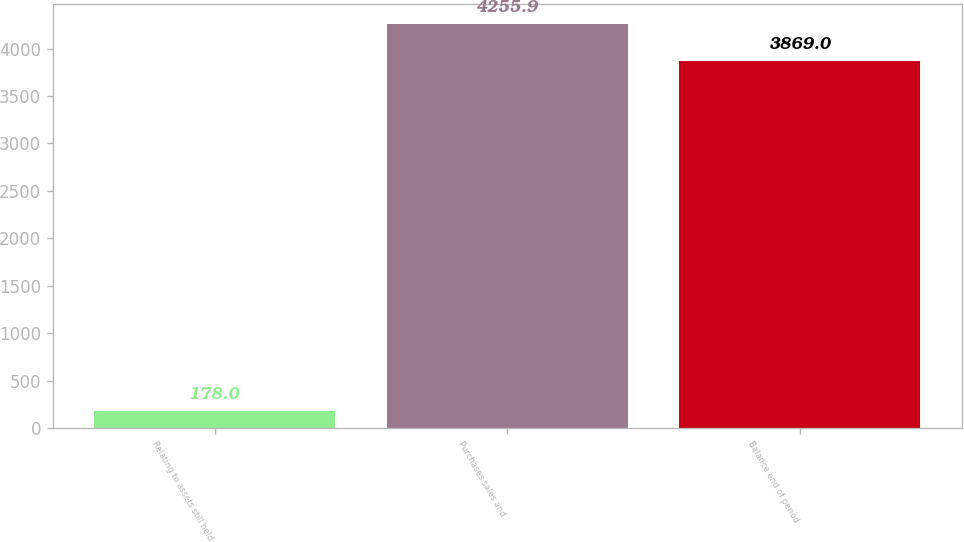Convert chart to OTSL. <chart><loc_0><loc_0><loc_500><loc_500><bar_chart><fcel>Relating to assets still held<fcel>Purchases sales and<fcel>Balance end of period<nl><fcel>178<fcel>4255.9<fcel>3869<nl></chart> 